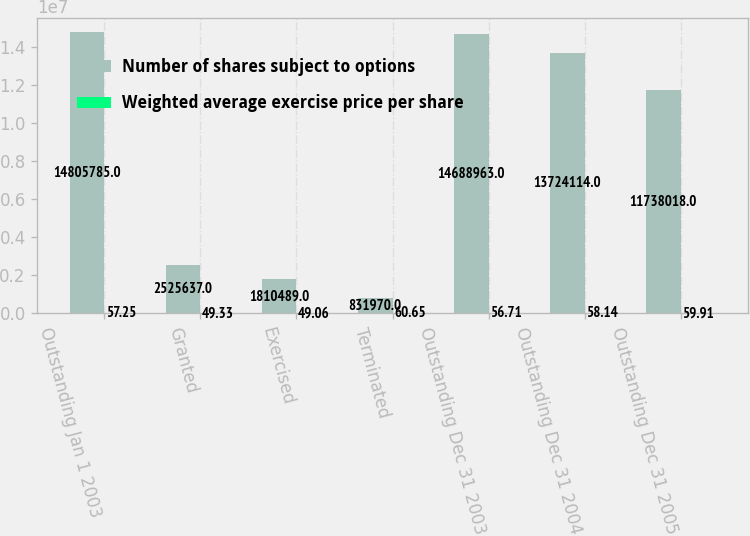<chart> <loc_0><loc_0><loc_500><loc_500><stacked_bar_chart><ecel><fcel>Outstanding Jan 1 2003<fcel>Granted<fcel>Exercised<fcel>Terminated<fcel>Outstanding Dec 31 2003<fcel>Outstanding Dec 31 2004<fcel>Outstanding Dec 31 2005<nl><fcel>Number of shares subject to options<fcel>1.48058e+07<fcel>2.52564e+06<fcel>1.81049e+06<fcel>831970<fcel>1.4689e+07<fcel>1.37241e+07<fcel>1.1738e+07<nl><fcel>Weighted average exercise price per share<fcel>57.25<fcel>49.33<fcel>49.06<fcel>60.65<fcel>56.71<fcel>58.14<fcel>59.91<nl></chart> 